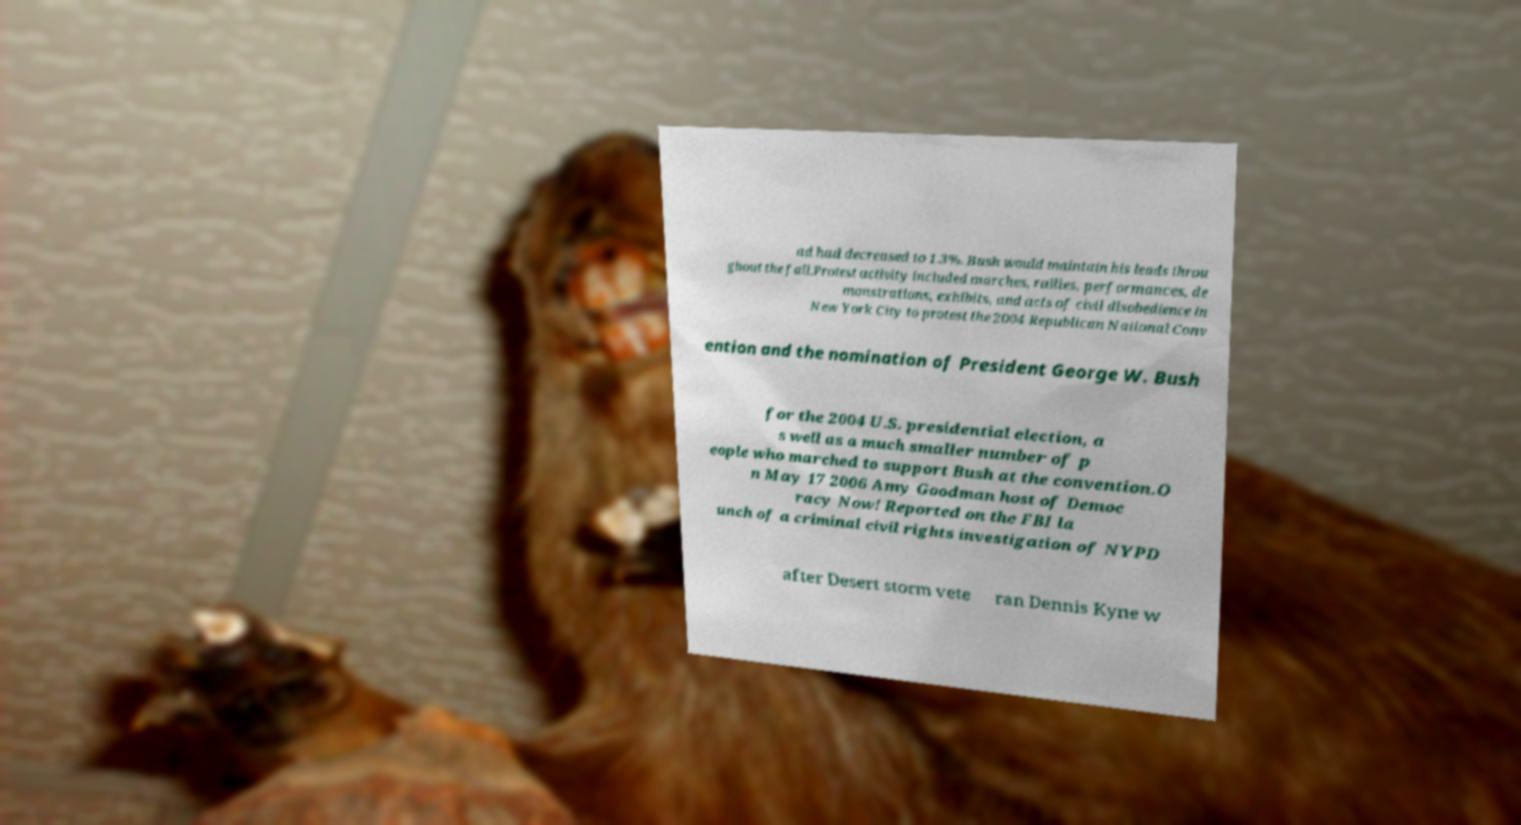There's text embedded in this image that I need extracted. Can you transcribe it verbatim? ad had decreased to 1.3%. Bush would maintain his leads throu ghout the fall.Protest activity included marches, rallies, performances, de monstrations, exhibits, and acts of civil disobedience in New York City to protest the 2004 Republican National Conv ention and the nomination of President George W. Bush for the 2004 U.S. presidential election, a s well as a much smaller number of p eople who marched to support Bush at the convention.O n May 17 2006 Amy Goodman host of Democ racy Now! Reported on the FBI la unch of a criminal civil rights investigation of NYPD after Desert storm vete ran Dennis Kyne w 